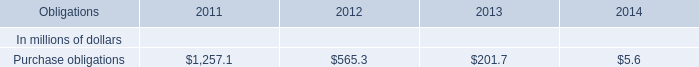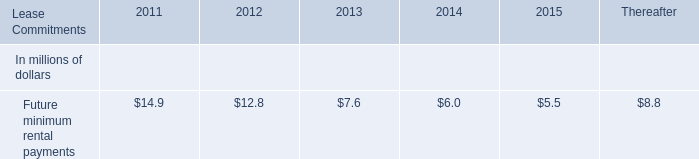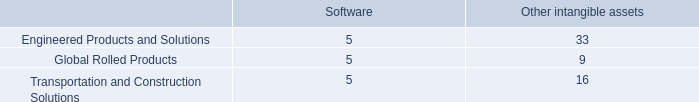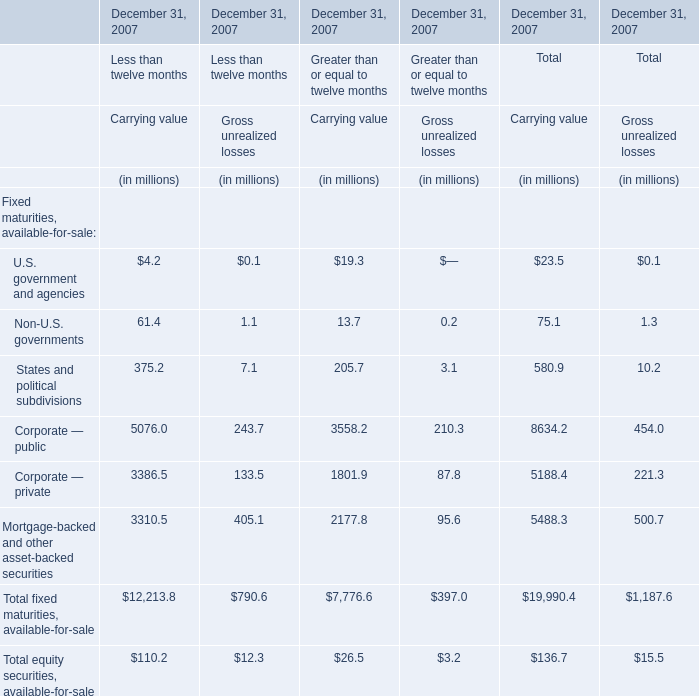What's the total value of all elements that are smaller than 100 for Carrying value of Less than twelve months? (in million) 
Computations: (4.2 + 61.4)
Answer: 65.6. 